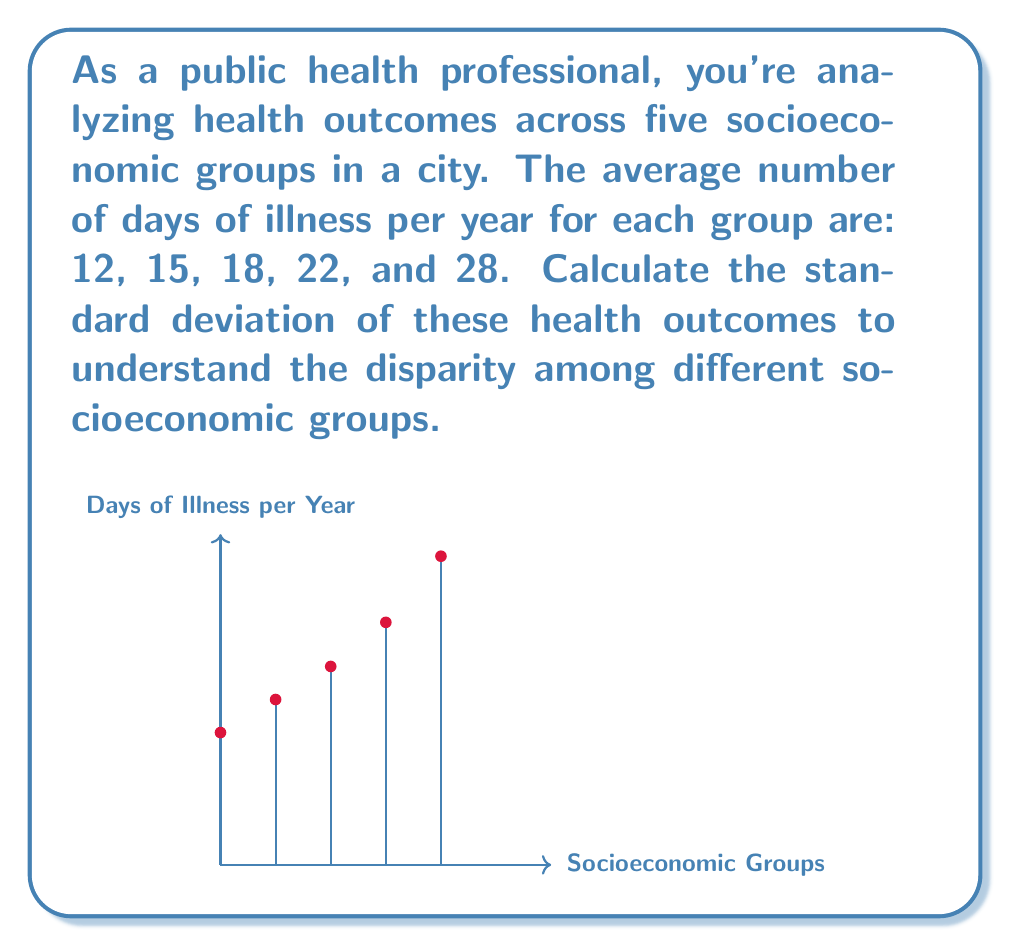Give your solution to this math problem. To calculate the standard deviation, we'll follow these steps:

1) First, calculate the mean ($\mu$) of the data:
   $$\mu = \frac{12 + 15 + 18 + 22 + 28}{5} = 19$$

2) Calculate the squared differences from the mean:
   $$(12-19)^2 = (-7)^2 = 49$$
   $$(15-19)^2 = (-4)^2 = 16$$
   $$(18-19)^2 = (-1)^2 = 1$$
   $$(22-19)^2 = (3)^2 = 9$$
   $$(28-19)^2 = (9)^2 = 81$$

3) Calculate the average of these squared differences:
   $$\frac{49 + 16 + 1 + 9 + 81}{5} = \frac{156}{5} = 31.2$$

4) Take the square root of this average to get the standard deviation:
   $$\sigma = \sqrt{31.2} = 5.59$$

Therefore, the standard deviation of health outcomes among the five socioeconomic groups is approximately 5.59 days.
Answer: $5.59$ days 